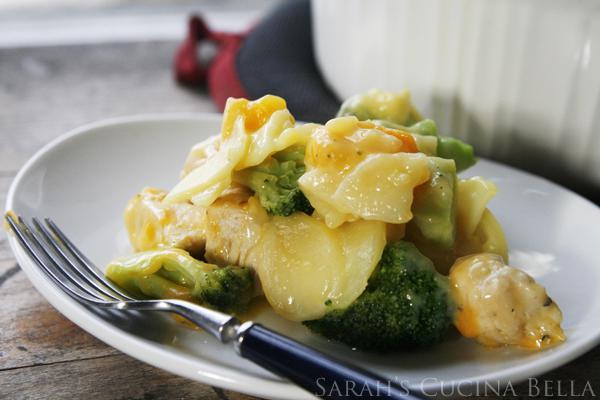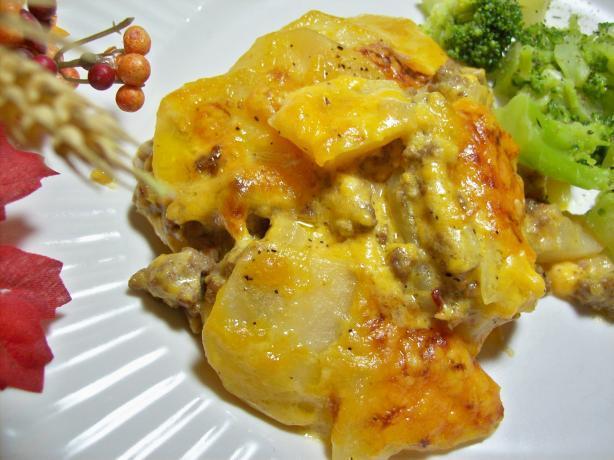The first image is the image on the left, the second image is the image on the right. Analyze the images presented: Is the assertion "The food is one a white plate in the image on the left." valid? Answer yes or no. Yes. The first image is the image on the left, the second image is the image on the right. Given the left and right images, does the statement "Both images show food served on an all-white dish." hold true? Answer yes or no. Yes. 